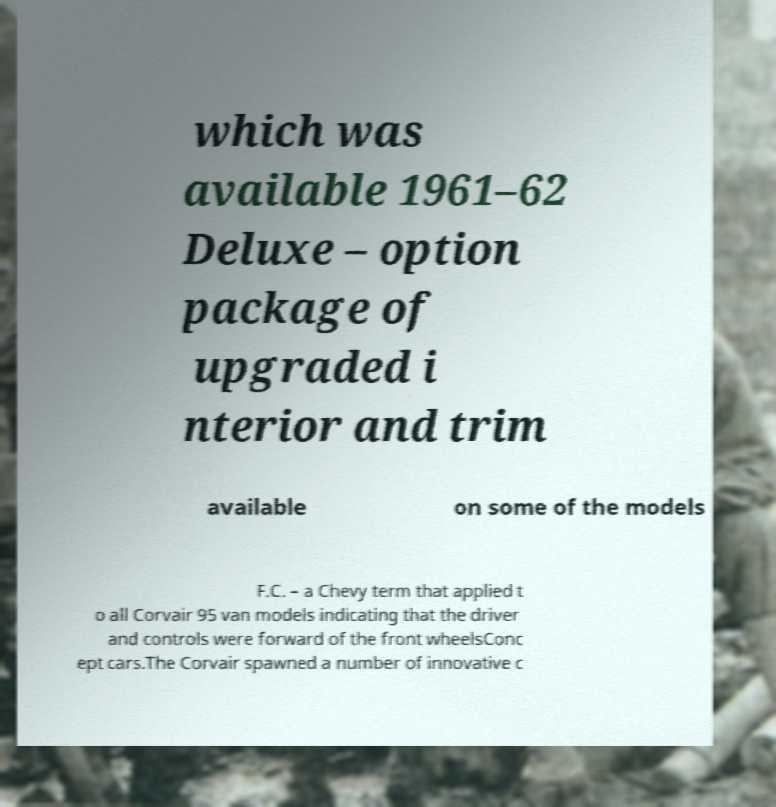There's text embedded in this image that I need extracted. Can you transcribe it verbatim? which was available 1961–62 Deluxe – option package of upgraded i nterior and trim available on some of the models F.C. – a Chevy term that applied t o all Corvair 95 van models indicating that the driver and controls were forward of the front wheelsConc ept cars.The Corvair spawned a number of innovative c 